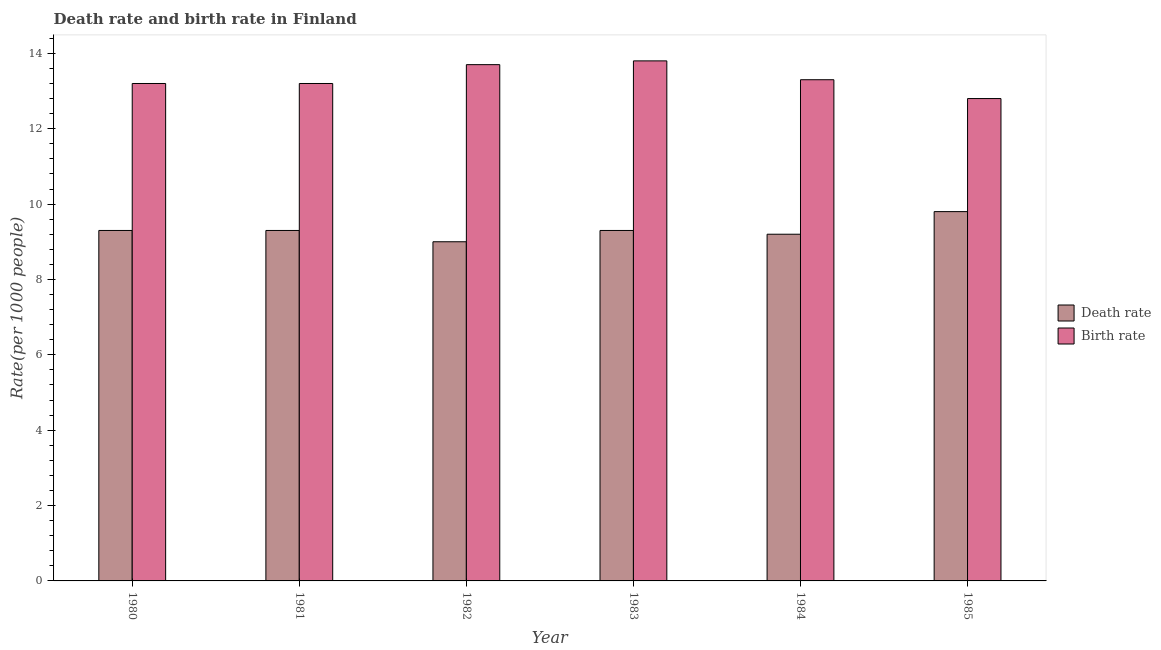How many different coloured bars are there?
Provide a short and direct response. 2. Are the number of bars on each tick of the X-axis equal?
Give a very brief answer. Yes. How many bars are there on the 4th tick from the left?
Your answer should be very brief. 2. How many bars are there on the 1st tick from the right?
Provide a succinct answer. 2. In how many cases, is the number of bars for a given year not equal to the number of legend labels?
Your answer should be very brief. 0. Across all years, what is the minimum birth rate?
Your answer should be compact. 12.8. What is the total birth rate in the graph?
Offer a terse response. 80. What is the difference between the death rate in 1984 and that in 1985?
Make the answer very short. -0.6. What is the difference between the birth rate in 1984 and the death rate in 1981?
Your answer should be very brief. 0.1. What is the average birth rate per year?
Provide a succinct answer. 13.33. What is the ratio of the death rate in 1981 to that in 1982?
Make the answer very short. 1.03. Is the birth rate in 1981 less than that in 1982?
Offer a terse response. Yes. What is the difference between the highest and the second highest birth rate?
Ensure brevity in your answer.  0.1. What is the difference between the highest and the lowest birth rate?
Offer a terse response. 1. In how many years, is the birth rate greater than the average birth rate taken over all years?
Your answer should be compact. 2. What does the 1st bar from the left in 1984 represents?
Your response must be concise. Death rate. What does the 1st bar from the right in 1982 represents?
Provide a short and direct response. Birth rate. How many bars are there?
Offer a very short reply. 12. Are all the bars in the graph horizontal?
Offer a terse response. No. Are the values on the major ticks of Y-axis written in scientific E-notation?
Offer a terse response. No. Does the graph contain any zero values?
Offer a very short reply. No. Does the graph contain grids?
Make the answer very short. No. How are the legend labels stacked?
Your response must be concise. Vertical. What is the title of the graph?
Your answer should be very brief. Death rate and birth rate in Finland. Does "Public credit registry" appear as one of the legend labels in the graph?
Offer a terse response. No. What is the label or title of the Y-axis?
Ensure brevity in your answer.  Rate(per 1000 people). What is the Rate(per 1000 people) in Birth rate in 1980?
Make the answer very short. 13.2. What is the Rate(per 1000 people) in Birth rate in 1983?
Your response must be concise. 13.8. What is the Rate(per 1000 people) of Death rate in 1985?
Your answer should be very brief. 9.8. Across all years, what is the maximum Rate(per 1000 people) of Death rate?
Your response must be concise. 9.8. Across all years, what is the maximum Rate(per 1000 people) of Birth rate?
Your answer should be compact. 13.8. What is the total Rate(per 1000 people) in Death rate in the graph?
Keep it short and to the point. 55.9. What is the total Rate(per 1000 people) of Birth rate in the graph?
Offer a very short reply. 80. What is the difference between the Rate(per 1000 people) in Death rate in 1980 and that in 1981?
Make the answer very short. 0. What is the difference between the Rate(per 1000 people) of Birth rate in 1980 and that in 1981?
Provide a succinct answer. 0. What is the difference between the Rate(per 1000 people) in Death rate in 1980 and that in 1982?
Provide a succinct answer. 0.3. What is the difference between the Rate(per 1000 people) of Birth rate in 1980 and that in 1982?
Provide a succinct answer. -0.5. What is the difference between the Rate(per 1000 people) in Death rate in 1980 and that in 1983?
Offer a terse response. 0. What is the difference between the Rate(per 1000 people) of Birth rate in 1980 and that in 1983?
Your answer should be compact. -0.6. What is the difference between the Rate(per 1000 people) of Death rate in 1980 and that in 1985?
Keep it short and to the point. -0.5. What is the difference between the Rate(per 1000 people) of Birth rate in 1980 and that in 1985?
Provide a short and direct response. 0.4. What is the difference between the Rate(per 1000 people) in Death rate in 1981 and that in 1982?
Offer a very short reply. 0.3. What is the difference between the Rate(per 1000 people) in Birth rate in 1981 and that in 1982?
Give a very brief answer. -0.5. What is the difference between the Rate(per 1000 people) in Birth rate in 1981 and that in 1983?
Offer a very short reply. -0.6. What is the difference between the Rate(per 1000 people) of Birth rate in 1981 and that in 1984?
Ensure brevity in your answer.  -0.1. What is the difference between the Rate(per 1000 people) of Death rate in 1981 and that in 1985?
Make the answer very short. -0.5. What is the difference between the Rate(per 1000 people) of Death rate in 1982 and that in 1983?
Give a very brief answer. -0.3. What is the difference between the Rate(per 1000 people) in Birth rate in 1982 and that in 1983?
Your response must be concise. -0.1. What is the difference between the Rate(per 1000 people) of Death rate in 1982 and that in 1984?
Ensure brevity in your answer.  -0.2. What is the difference between the Rate(per 1000 people) in Birth rate in 1982 and that in 1984?
Provide a succinct answer. 0.4. What is the difference between the Rate(per 1000 people) in Birth rate in 1982 and that in 1985?
Provide a short and direct response. 0.9. What is the difference between the Rate(per 1000 people) in Birth rate in 1983 and that in 1984?
Your answer should be compact. 0.5. What is the difference between the Rate(per 1000 people) in Death rate in 1983 and that in 1985?
Offer a very short reply. -0.5. What is the difference between the Rate(per 1000 people) in Birth rate in 1983 and that in 1985?
Your answer should be very brief. 1. What is the difference between the Rate(per 1000 people) of Death rate in 1984 and that in 1985?
Your answer should be compact. -0.6. What is the difference between the Rate(per 1000 people) of Birth rate in 1984 and that in 1985?
Make the answer very short. 0.5. What is the difference between the Rate(per 1000 people) in Death rate in 1980 and the Rate(per 1000 people) in Birth rate in 1984?
Provide a short and direct response. -4. What is the difference between the Rate(per 1000 people) in Death rate in 1980 and the Rate(per 1000 people) in Birth rate in 1985?
Your response must be concise. -3.5. What is the difference between the Rate(per 1000 people) of Death rate in 1981 and the Rate(per 1000 people) of Birth rate in 1984?
Provide a short and direct response. -4. What is the difference between the Rate(per 1000 people) of Death rate in 1982 and the Rate(per 1000 people) of Birth rate in 1984?
Provide a short and direct response. -4.3. What is the difference between the Rate(per 1000 people) of Death rate in 1982 and the Rate(per 1000 people) of Birth rate in 1985?
Your answer should be very brief. -3.8. What is the difference between the Rate(per 1000 people) in Death rate in 1983 and the Rate(per 1000 people) in Birth rate in 1985?
Offer a very short reply. -3.5. What is the difference between the Rate(per 1000 people) in Death rate in 1984 and the Rate(per 1000 people) in Birth rate in 1985?
Your answer should be compact. -3.6. What is the average Rate(per 1000 people) in Death rate per year?
Keep it short and to the point. 9.32. What is the average Rate(per 1000 people) of Birth rate per year?
Provide a short and direct response. 13.33. In the year 1980, what is the difference between the Rate(per 1000 people) of Death rate and Rate(per 1000 people) of Birth rate?
Your response must be concise. -3.9. In the year 1982, what is the difference between the Rate(per 1000 people) of Death rate and Rate(per 1000 people) of Birth rate?
Your answer should be very brief. -4.7. In the year 1983, what is the difference between the Rate(per 1000 people) in Death rate and Rate(per 1000 people) in Birth rate?
Make the answer very short. -4.5. What is the ratio of the Rate(per 1000 people) of Birth rate in 1980 to that in 1981?
Make the answer very short. 1. What is the ratio of the Rate(per 1000 people) in Birth rate in 1980 to that in 1982?
Ensure brevity in your answer.  0.96. What is the ratio of the Rate(per 1000 people) of Birth rate in 1980 to that in 1983?
Make the answer very short. 0.96. What is the ratio of the Rate(per 1000 people) of Death rate in 1980 to that in 1984?
Provide a succinct answer. 1.01. What is the ratio of the Rate(per 1000 people) in Death rate in 1980 to that in 1985?
Provide a short and direct response. 0.95. What is the ratio of the Rate(per 1000 people) in Birth rate in 1980 to that in 1985?
Make the answer very short. 1.03. What is the ratio of the Rate(per 1000 people) of Death rate in 1981 to that in 1982?
Ensure brevity in your answer.  1.03. What is the ratio of the Rate(per 1000 people) of Birth rate in 1981 to that in 1982?
Make the answer very short. 0.96. What is the ratio of the Rate(per 1000 people) in Death rate in 1981 to that in 1983?
Give a very brief answer. 1. What is the ratio of the Rate(per 1000 people) of Birth rate in 1981 to that in 1983?
Your answer should be very brief. 0.96. What is the ratio of the Rate(per 1000 people) in Death rate in 1981 to that in 1984?
Ensure brevity in your answer.  1.01. What is the ratio of the Rate(per 1000 people) of Death rate in 1981 to that in 1985?
Your answer should be very brief. 0.95. What is the ratio of the Rate(per 1000 people) of Birth rate in 1981 to that in 1985?
Ensure brevity in your answer.  1.03. What is the ratio of the Rate(per 1000 people) in Death rate in 1982 to that in 1984?
Make the answer very short. 0.98. What is the ratio of the Rate(per 1000 people) of Birth rate in 1982 to that in 1984?
Offer a terse response. 1.03. What is the ratio of the Rate(per 1000 people) in Death rate in 1982 to that in 1985?
Your response must be concise. 0.92. What is the ratio of the Rate(per 1000 people) of Birth rate in 1982 to that in 1985?
Make the answer very short. 1.07. What is the ratio of the Rate(per 1000 people) in Death rate in 1983 to that in 1984?
Keep it short and to the point. 1.01. What is the ratio of the Rate(per 1000 people) in Birth rate in 1983 to that in 1984?
Your answer should be compact. 1.04. What is the ratio of the Rate(per 1000 people) of Death rate in 1983 to that in 1985?
Ensure brevity in your answer.  0.95. What is the ratio of the Rate(per 1000 people) in Birth rate in 1983 to that in 1985?
Ensure brevity in your answer.  1.08. What is the ratio of the Rate(per 1000 people) of Death rate in 1984 to that in 1985?
Your response must be concise. 0.94. What is the ratio of the Rate(per 1000 people) of Birth rate in 1984 to that in 1985?
Your response must be concise. 1.04. 